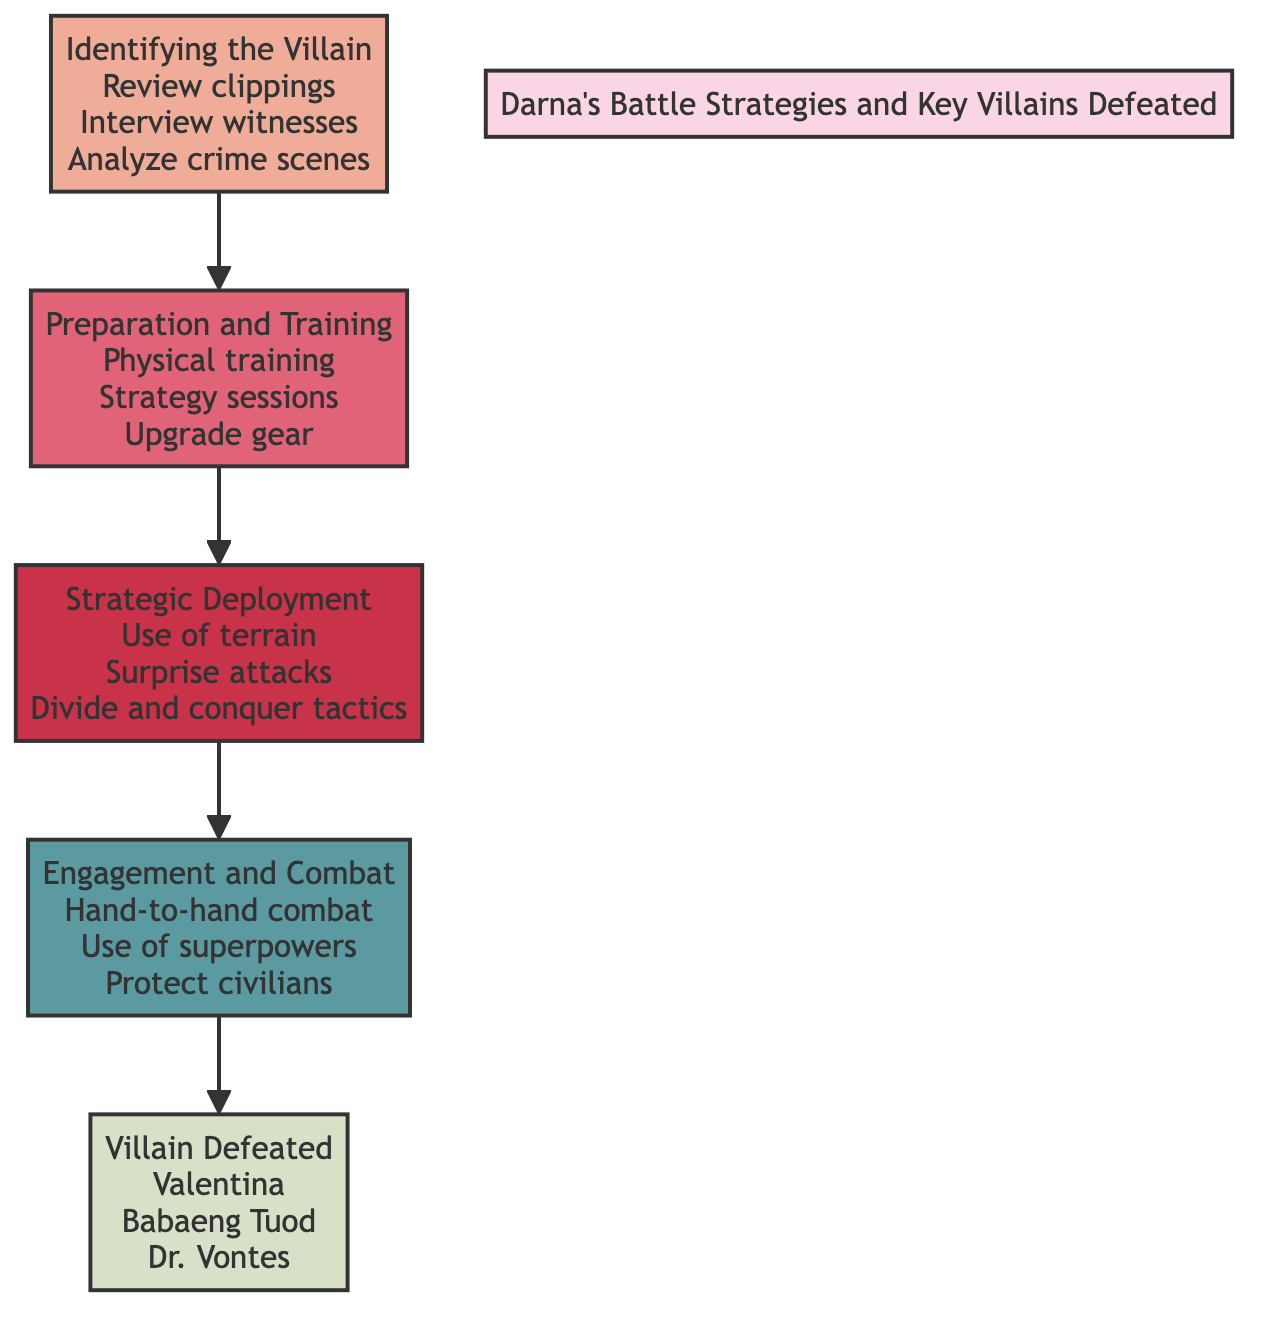What is the first step in Darna's battle strategy? The first step is "Identifying the Villain," which involves gathering intel and analyzing the villain’s weaknesses.
Answer: Identifying the Villain How many villains are listed as defeated by Darna? In the final node "Villain Defeated," there are three villains named: Valentina, Babaeng Tuod, and Dr. Vontes.
Answer: 3 Which level describes Darna's engagement in combat? The level that describes this stage is "Engagement and Combat," where she uses various techniques including hand-to-hand combat and superpowers.
Answer: Engagement and Combat What action is included in the "Preparation and Training" phase? One of the actions mentioned in this phase is "Physical training," which signals how Darna gets ready for battle.
Answer: Physical training Which phase comes before "Strategic Deployment"? The phase "Preparation and Training" comes just before "Strategic Deployment" in the flow chart, indicating a chronological order of actions taken.
Answer: Preparation and Training What are the focus techniques in the "Engagement and Combat" stage? The techniques used in this stage include hand-to-hand combat, use of superpowers, and protecting civilians.
Answer: Hand-to-hand combat, use of superpowers, protect civilians What is the last action in Darna's battle strategies? The last action in the battle strategy flowchart is "Villain Defeated," which confirms that she has successfully overcome the threats.
Answer: Villain Defeated What specific tactic is mentioned under "Strategic Deployment"? One specific tactic mentioned is "Surprise attacks," which illustrates Darna's strategic approach in battles.
Answer: Surprise attacks Which stage in the flow chart does "Analyzing crime scenes" belong to? "Analyzing crime scenes" is part of the first level, specifically under the phase "Identifying the Villain."
Answer: Identifying the Villain 